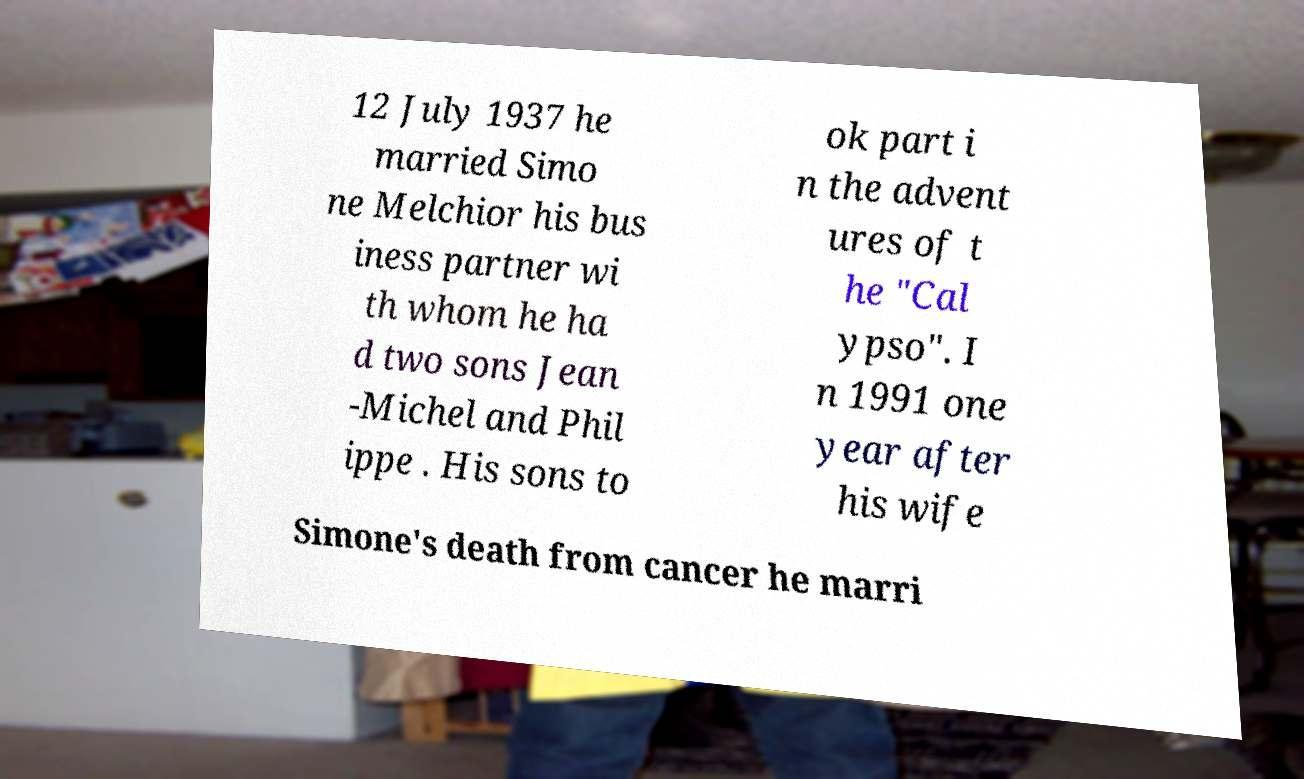Could you assist in decoding the text presented in this image and type it out clearly? 12 July 1937 he married Simo ne Melchior his bus iness partner wi th whom he ha d two sons Jean -Michel and Phil ippe . His sons to ok part i n the advent ures of t he "Cal ypso". I n 1991 one year after his wife Simone's death from cancer he marri 